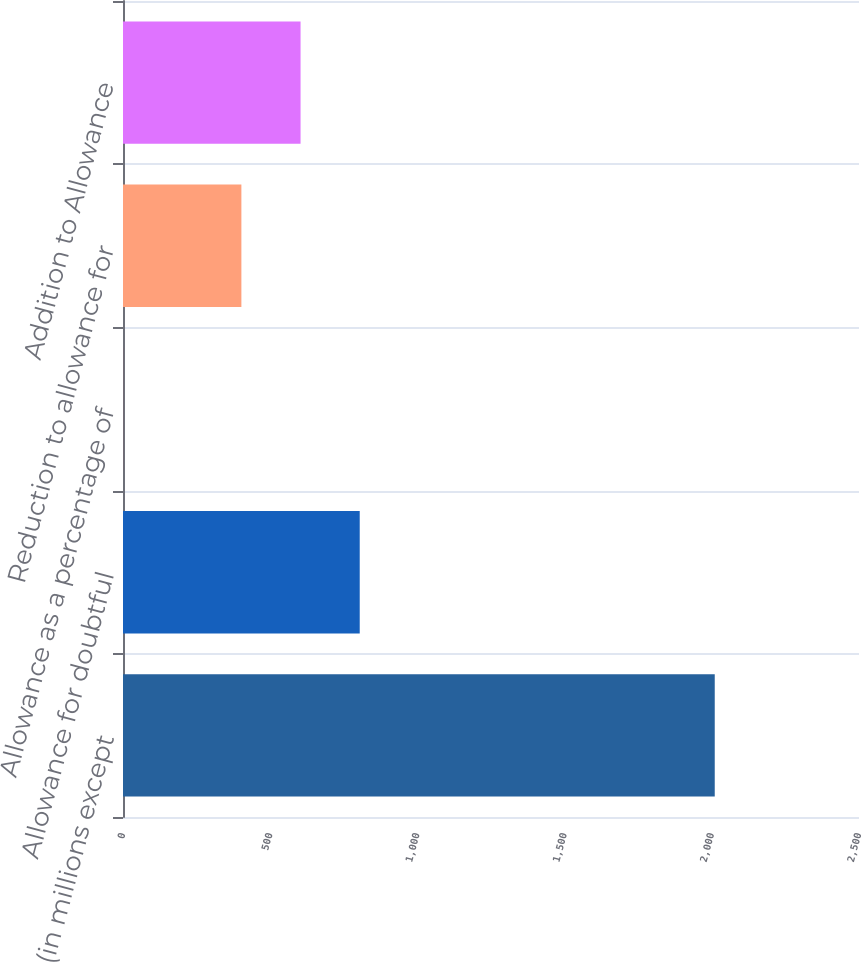Convert chart. <chart><loc_0><loc_0><loc_500><loc_500><bar_chart><fcel>(in millions except<fcel>Allowance for doubtful<fcel>Allowance as a percentage of<fcel>Reduction to allowance for<fcel>Addition to Allowance<nl><fcel>2010<fcel>804.1<fcel>0.14<fcel>402.12<fcel>603.11<nl></chart> 